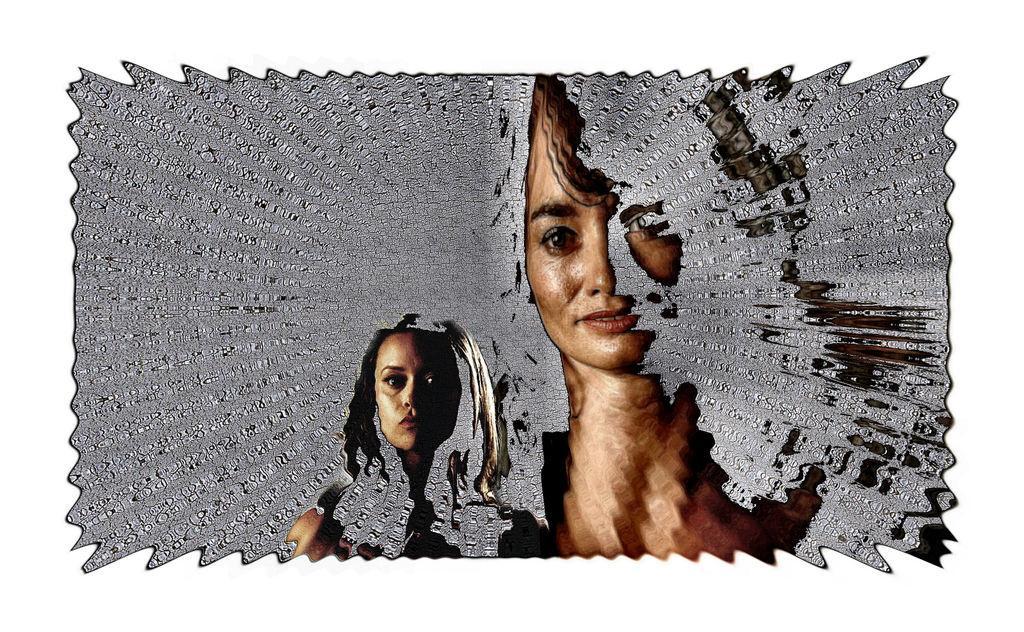In one or two sentences, can you explain what this image depicts? It is the graphic image in which we can see the two girls one beside the other. There is some blue on their faces. 